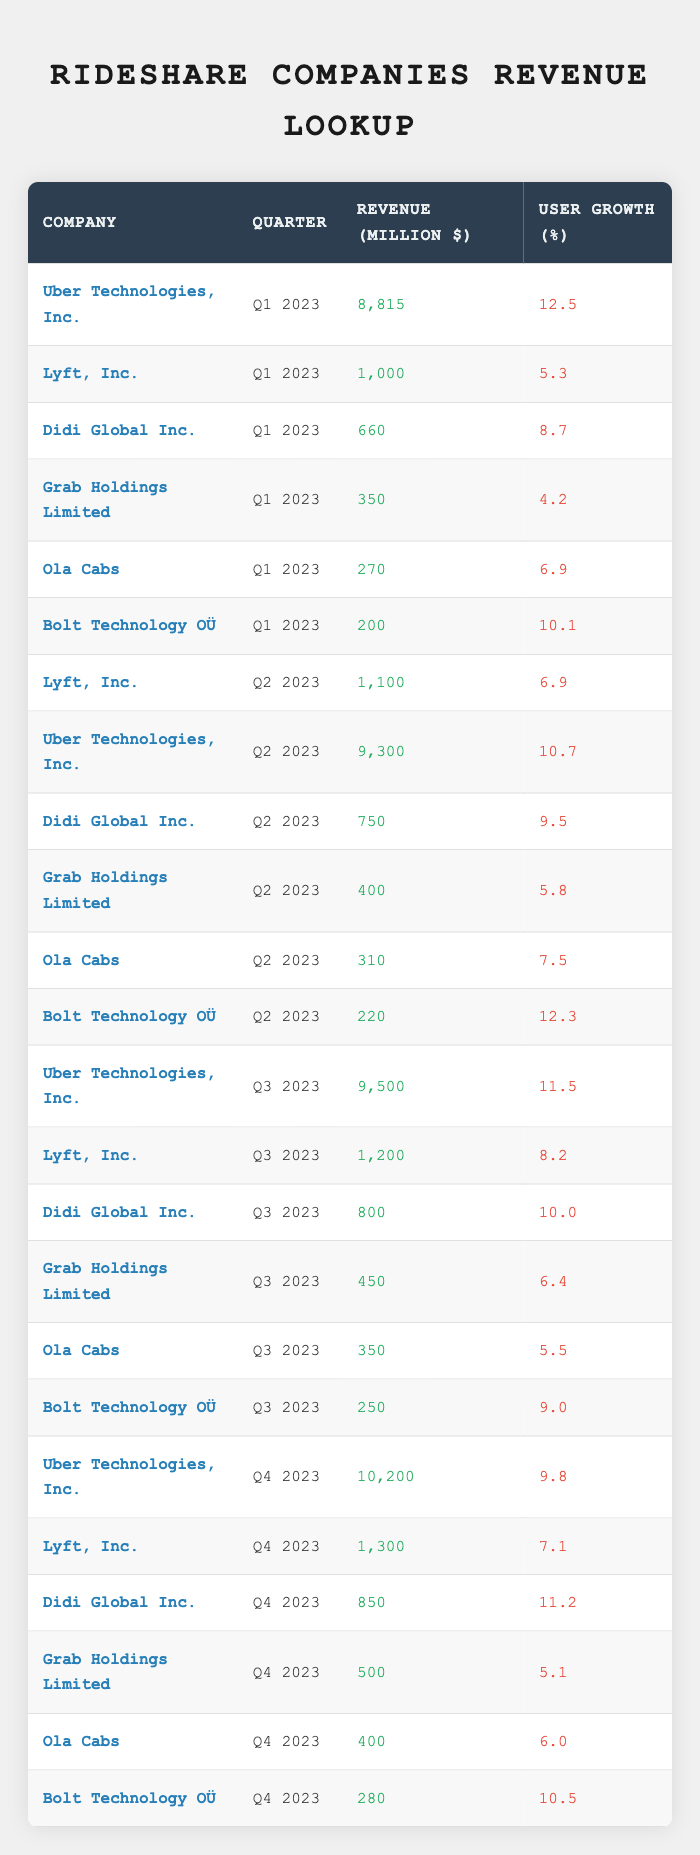What is the highest revenue recorded by any rideshare company in Q1 2023? Looking at the table, Uber Technologies, Inc. recorded the highest revenue in Q1 2023, with a revenue of 8,815 million dollars compared to other companies listed.
Answer: 8,815 million dollars Which company had the lowest user growth percentage in Q2 2023? In Q2 2023, Grab Holdings Limited had the lowest user growth percentage at 5.8%, while other companies had higher percentages.
Answer: Grab Holdings Limited What is the total revenue generated by Uber Technologies, Inc. across all quarters in 2023? By adding Uber's quarterly revenues: 8,815 (Q1) + 9,300 (Q2) + 9,500 (Q3) + 10,200 (Q4), the total revenue is calculated as 8,815 + 9,300 + 9,500 + 10,200 = 37,815 million dollars.
Answer: 37,815 million dollars Did Lyft, Inc. experience an increase in revenue from Q2 2023 to Q3 2023? Comparing the revenues, Lyft had 1,100 million dollars in Q2 2023 and 1,200 million dollars in Q3 2023, indicating that there was indeed an increase in revenue.
Answer: Yes Which company consistently had user growth rates above 10% in all quarters? Examining the user growth rates: Uber had 12.5% (Q1), 10.7% (Q2), 11.5% (Q3), and 9.8% (Q4). Although Uber had impressive growth rates, there was no quarter where all remained above 10%. Therefore, no company fulfilled this criterion across all quarters.
Answer: No 